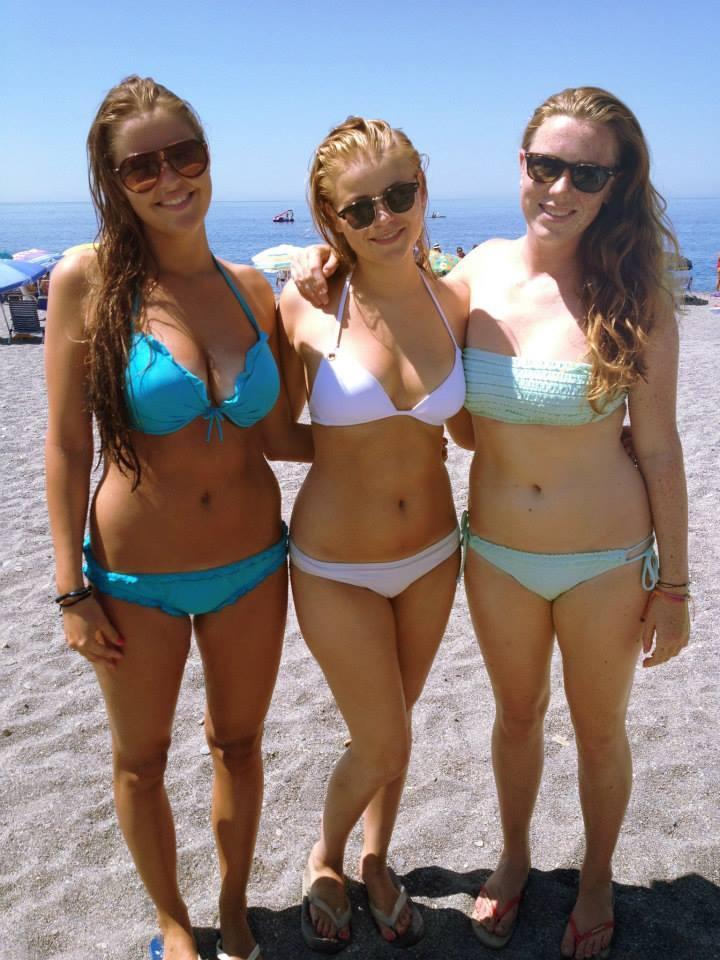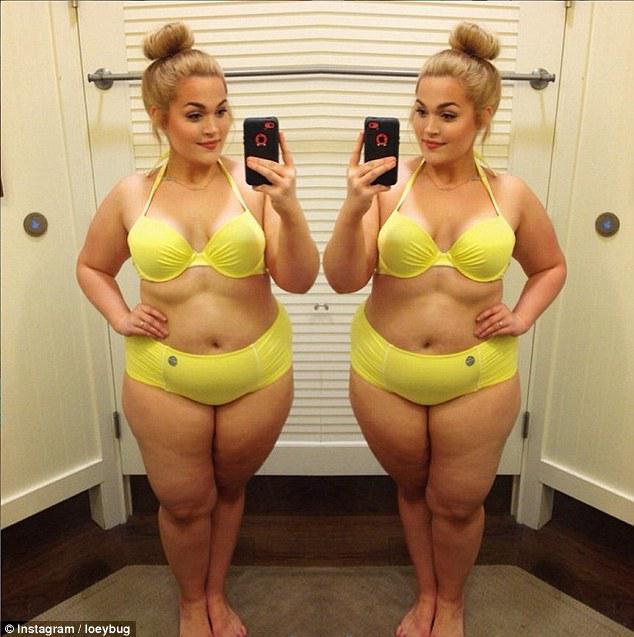The first image is the image on the left, the second image is the image on the right. For the images shown, is this caption "A woman is holding a phone." true? Answer yes or no. Yes. The first image is the image on the left, the second image is the image on the right. Assess this claim about the two images: "There are five women in two pieces suits.". Correct or not? Answer yes or no. Yes. 